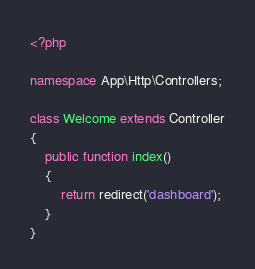Convert code to text. <code><loc_0><loc_0><loc_500><loc_500><_PHP_><?php

namespace App\Http\Controllers;

class Welcome extends Controller
{
    public function index()
    {
        return redirect('dashboard');
    }
}
</code> 